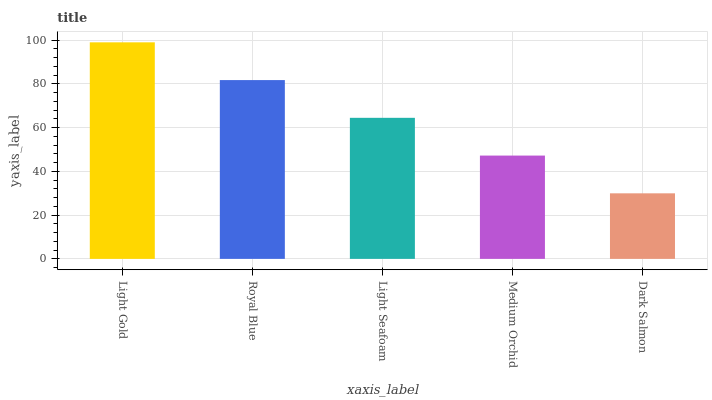Is Dark Salmon the minimum?
Answer yes or no. Yes. Is Light Gold the maximum?
Answer yes or no. Yes. Is Royal Blue the minimum?
Answer yes or no. No. Is Royal Blue the maximum?
Answer yes or no. No. Is Light Gold greater than Royal Blue?
Answer yes or no. Yes. Is Royal Blue less than Light Gold?
Answer yes or no. Yes. Is Royal Blue greater than Light Gold?
Answer yes or no. No. Is Light Gold less than Royal Blue?
Answer yes or no. No. Is Light Seafoam the high median?
Answer yes or no. Yes. Is Light Seafoam the low median?
Answer yes or no. Yes. Is Light Gold the high median?
Answer yes or no. No. Is Light Gold the low median?
Answer yes or no. No. 